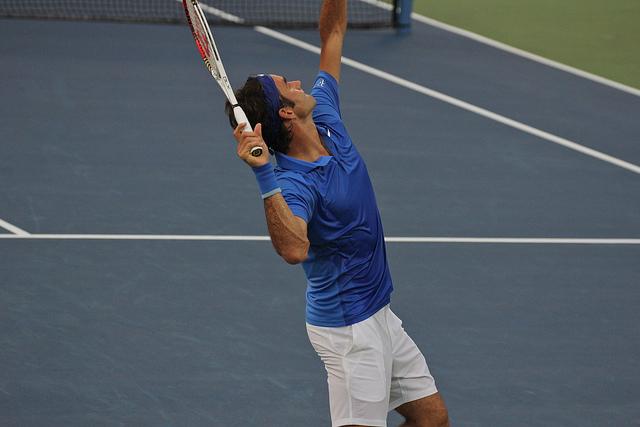What gender is this person?
Quick response, please. Male. What color is the shirt?
Answer briefly. Blue. What color is the tennis racket?
Quick response, please. White. What color is the man's shirt?
Short answer required. Blue. What color is the man's headband?
Write a very short answer. Blue. What position does this man play?
Answer briefly. Server. Is the man beginning or finishing his swing?
Quick response, please. Beginning. What is the color of the wristband?
Quick response, please. Blue. Is the man playing tennis in a stadium?
Short answer required. Yes. Is he serving?
Quick response, please. Yes. What is the man wearing on his wrist?
Give a very brief answer. Wristband. What game is he playing?
Answer briefly. Tennis. 